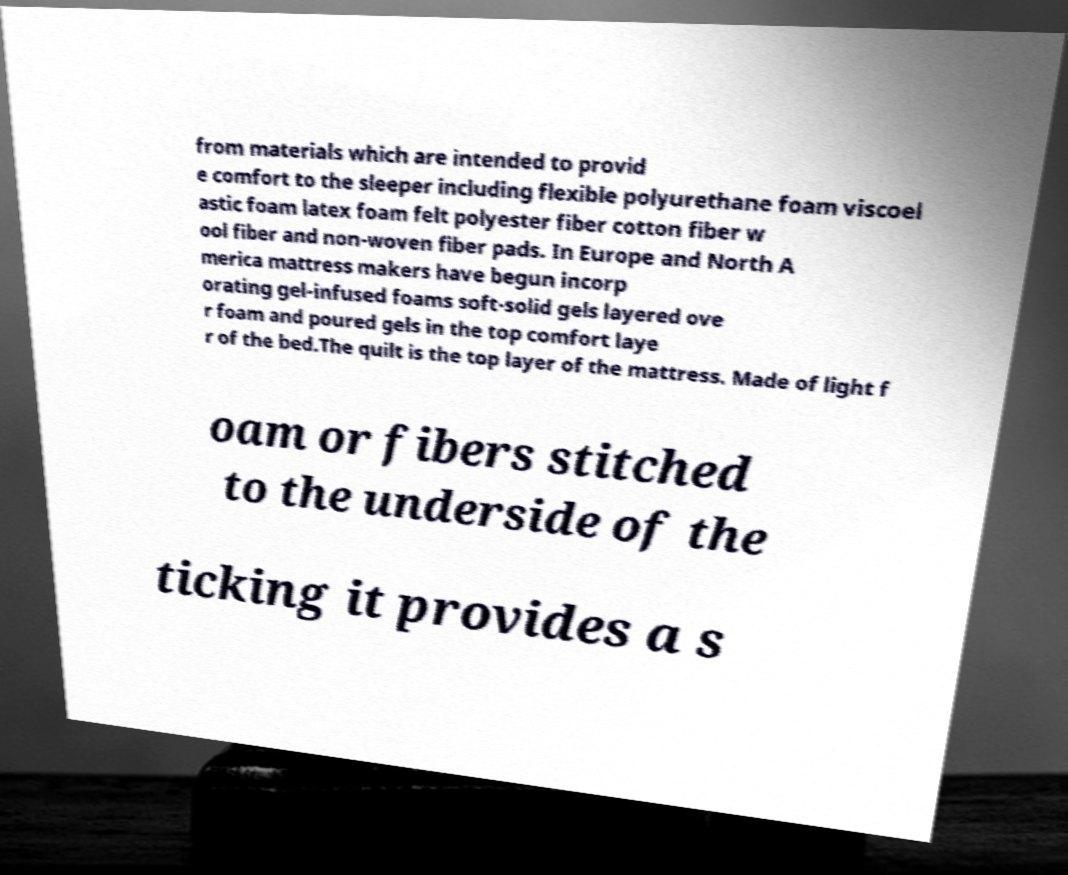Can you accurately transcribe the text from the provided image for me? from materials which are intended to provid e comfort to the sleeper including flexible polyurethane foam viscoel astic foam latex foam felt polyester fiber cotton fiber w ool fiber and non-woven fiber pads. In Europe and North A merica mattress makers have begun incorp orating gel-infused foams soft-solid gels layered ove r foam and poured gels in the top comfort laye r of the bed.The quilt is the top layer of the mattress. Made of light f oam or fibers stitched to the underside of the ticking it provides a s 